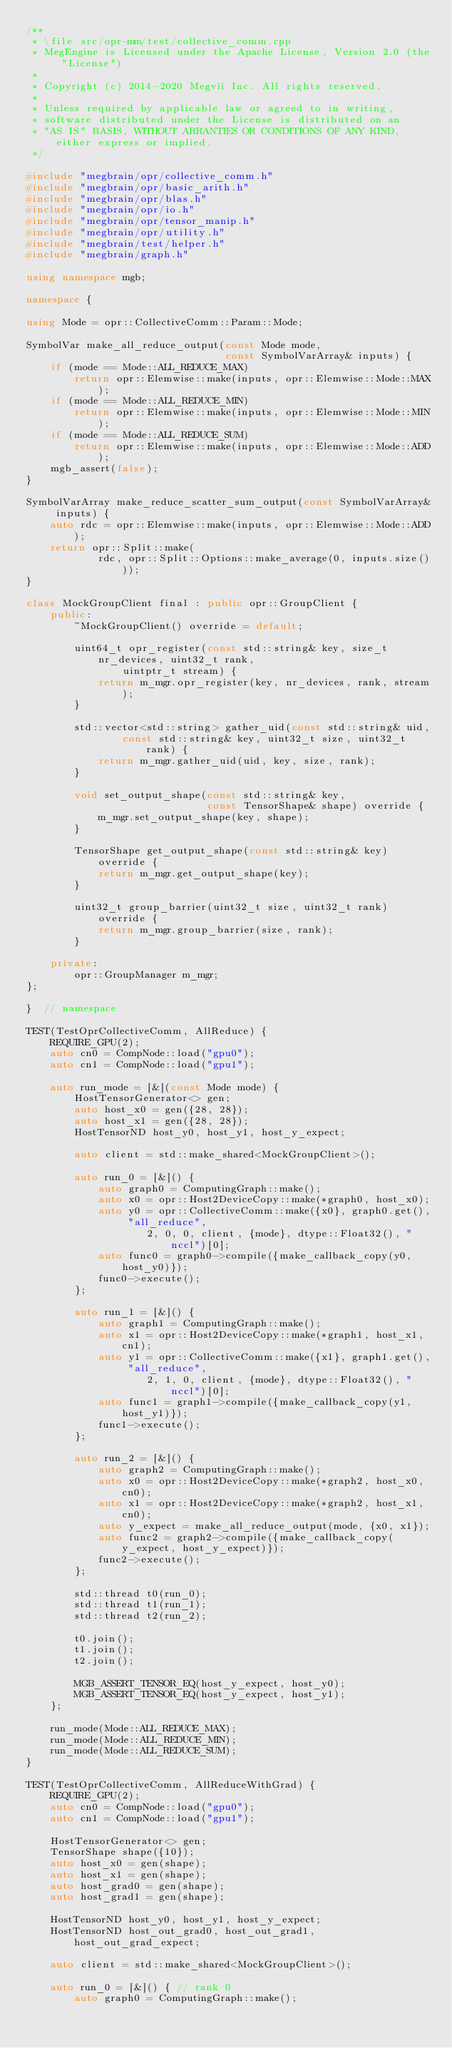Convert code to text. <code><loc_0><loc_0><loc_500><loc_500><_C++_>/**
 * \file src/opr-mm/test/collective_comm.cpp
 * MegEngine is Licensed under the Apache License, Version 2.0 (the "License")
 *
 * Copyright (c) 2014-2020 Megvii Inc. All rights reserved.
 *
 * Unless required by applicable law or agreed to in writing,
 * software distributed under the License is distributed on an
 * "AS IS" BASIS, WITHOUT ARRANTIES OR CONDITIONS OF ANY KIND, either express or implied.
 */

#include "megbrain/opr/collective_comm.h"
#include "megbrain/opr/basic_arith.h"
#include "megbrain/opr/blas.h"
#include "megbrain/opr/io.h"
#include "megbrain/opr/tensor_manip.h"
#include "megbrain/opr/utility.h"
#include "megbrain/test/helper.h"
#include "megbrain/graph.h"

using namespace mgb;

namespace {

using Mode = opr::CollectiveComm::Param::Mode;

SymbolVar make_all_reduce_output(const Mode mode,
                                 const SymbolVarArray& inputs) {
    if (mode == Mode::ALL_REDUCE_MAX)
        return opr::Elemwise::make(inputs, opr::Elemwise::Mode::MAX);
    if (mode == Mode::ALL_REDUCE_MIN)
        return opr::Elemwise::make(inputs, opr::Elemwise::Mode::MIN);
    if (mode == Mode::ALL_REDUCE_SUM)
        return opr::Elemwise::make(inputs, opr::Elemwise::Mode::ADD);
    mgb_assert(false);
}

SymbolVarArray make_reduce_scatter_sum_output(const SymbolVarArray& inputs) {
    auto rdc = opr::Elemwise::make(inputs, opr::Elemwise::Mode::ADD);
    return opr::Split::make(
            rdc, opr::Split::Options::make_average(0, inputs.size()));
}

class MockGroupClient final : public opr::GroupClient {
    public:
        ~MockGroupClient() override = default;

        uint64_t opr_register(const std::string& key, size_t nr_devices, uint32_t rank,
                uintptr_t stream) {
            return m_mgr.opr_register(key, nr_devices, rank, stream);
        }

        std::vector<std::string> gather_uid(const std::string& uid,
                const std::string& key, uint32_t size, uint32_t rank) {
            return m_mgr.gather_uid(uid, key, size, rank);
        }

        void set_output_shape(const std::string& key,
                              const TensorShape& shape) override {
            m_mgr.set_output_shape(key, shape);
        }
    
        TensorShape get_output_shape(const std::string& key) override {
            return m_mgr.get_output_shape(key);
        }

        uint32_t group_barrier(uint32_t size, uint32_t rank) override {
            return m_mgr.group_barrier(size, rank);
        }
    
    private:
        opr::GroupManager m_mgr;
};

}  // namespace

TEST(TestOprCollectiveComm, AllReduce) {
    REQUIRE_GPU(2);
    auto cn0 = CompNode::load("gpu0");
    auto cn1 = CompNode::load("gpu1");

    auto run_mode = [&](const Mode mode) {
        HostTensorGenerator<> gen;
        auto host_x0 = gen({28, 28});
        auto host_x1 = gen({28, 28});
        HostTensorND host_y0, host_y1, host_y_expect;

        auto client = std::make_shared<MockGroupClient>();

        auto run_0 = [&]() {
            auto graph0 = ComputingGraph::make();
            auto x0 = opr::Host2DeviceCopy::make(*graph0, host_x0);
            auto y0 = opr::CollectiveComm::make({x0}, graph0.get(), "all_reduce",
                    2, 0, 0, client, {mode}, dtype::Float32(), "nccl")[0];
            auto func0 = graph0->compile({make_callback_copy(y0, host_y0)});
            func0->execute();
        };

        auto run_1 = [&]() {
            auto graph1 = ComputingGraph::make();
            auto x1 = opr::Host2DeviceCopy::make(*graph1, host_x1, cn1);
            auto y1 = opr::CollectiveComm::make({x1}, graph1.get(), "all_reduce",
                    2, 1, 0, client, {mode}, dtype::Float32(), "nccl")[0];
            auto func1 = graph1->compile({make_callback_copy(y1, host_y1)});
            func1->execute();
        };

        auto run_2 = [&]() {
            auto graph2 = ComputingGraph::make();
            auto x0 = opr::Host2DeviceCopy::make(*graph2, host_x0, cn0);
            auto x1 = opr::Host2DeviceCopy::make(*graph2, host_x1, cn0);
            auto y_expect = make_all_reduce_output(mode, {x0, x1});
            auto func2 = graph2->compile({make_callback_copy(y_expect, host_y_expect)});
            func2->execute();
        };

        std::thread t0(run_0);
        std::thread t1(run_1);
        std::thread t2(run_2);

        t0.join();
        t1.join();
        t2.join();

        MGB_ASSERT_TENSOR_EQ(host_y_expect, host_y0);
        MGB_ASSERT_TENSOR_EQ(host_y_expect, host_y1);
    };

    run_mode(Mode::ALL_REDUCE_MAX);
    run_mode(Mode::ALL_REDUCE_MIN);
    run_mode(Mode::ALL_REDUCE_SUM);
}

TEST(TestOprCollectiveComm, AllReduceWithGrad) {
    REQUIRE_GPU(2);
    auto cn0 = CompNode::load("gpu0");
    auto cn1 = CompNode::load("gpu1");

    HostTensorGenerator<> gen;
    TensorShape shape({10});
    auto host_x0 = gen(shape);
    auto host_x1 = gen(shape);
    auto host_grad0 = gen(shape);
    auto host_grad1 = gen(shape);

    HostTensorND host_y0, host_y1, host_y_expect;
    HostTensorND host_out_grad0, host_out_grad1, host_out_grad_expect;

    auto client = std::make_shared<MockGroupClient>();

    auto run_0 = [&]() { // rank 0
        auto graph0 = ComputingGraph::make();</code> 